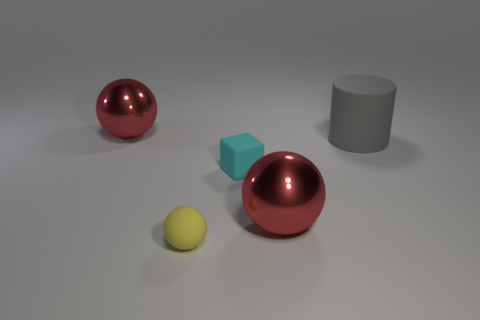Subtract all large red balls. How many balls are left? 1 Subtract all yellow balls. How many balls are left? 2 Subtract all spheres. How many objects are left? 2 Add 1 cylinders. How many objects exist? 6 Subtract all yellow cubes. How many purple cylinders are left? 0 Subtract all small blue rubber things. Subtract all big red shiny spheres. How many objects are left? 3 Add 5 big metallic spheres. How many big metallic spheres are left? 7 Add 2 blue cylinders. How many blue cylinders exist? 2 Subtract 2 red balls. How many objects are left? 3 Subtract all cyan balls. Subtract all yellow cubes. How many balls are left? 3 